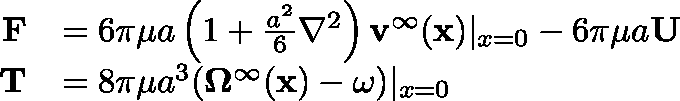<formula> <loc_0><loc_0><loc_500><loc_500>{ \begin{array} { r l } { F } & { = 6 \pi \mu a \left ( 1 + { \frac { a ^ { 2 } } { 6 } } \nabla ^ { 2 } \right ) v ^ { \infty } ( x ) | _ { x = 0 } - 6 \pi \mu a U } \\ { T } & { = 8 \pi \mu a ^ { 3 } ( \Omega ^ { \infty } ( x ) - \omega ) | _ { x = 0 } } \end{array} }</formula> 